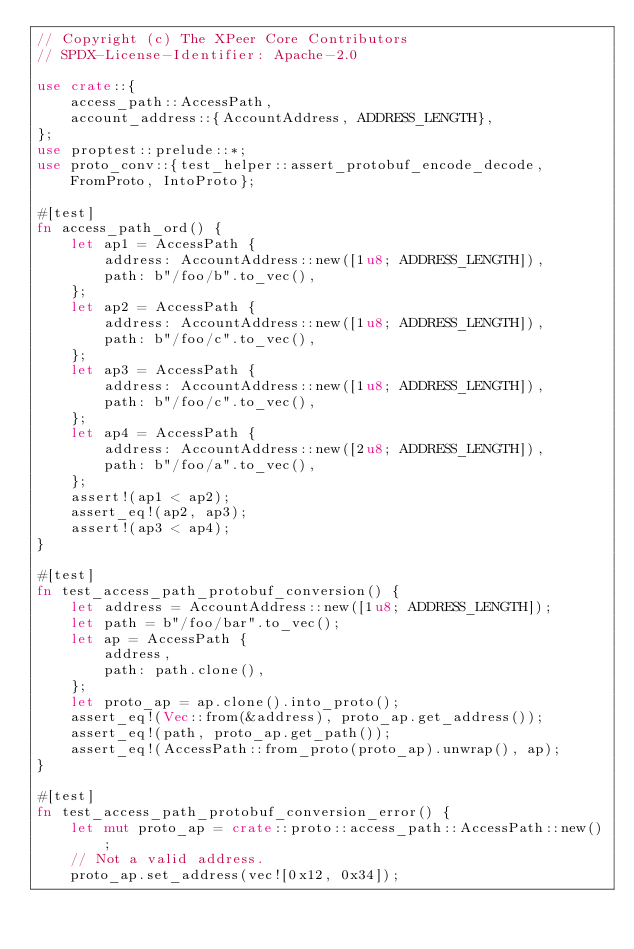Convert code to text. <code><loc_0><loc_0><loc_500><loc_500><_Rust_>// Copyright (c) The XPeer Core Contributors
// SPDX-License-Identifier: Apache-2.0

use crate::{
    access_path::AccessPath,
    account_address::{AccountAddress, ADDRESS_LENGTH},
};
use proptest::prelude::*;
use proto_conv::{test_helper::assert_protobuf_encode_decode, FromProto, IntoProto};

#[test]
fn access_path_ord() {
    let ap1 = AccessPath {
        address: AccountAddress::new([1u8; ADDRESS_LENGTH]),
        path: b"/foo/b".to_vec(),
    };
    let ap2 = AccessPath {
        address: AccountAddress::new([1u8; ADDRESS_LENGTH]),
        path: b"/foo/c".to_vec(),
    };
    let ap3 = AccessPath {
        address: AccountAddress::new([1u8; ADDRESS_LENGTH]),
        path: b"/foo/c".to_vec(),
    };
    let ap4 = AccessPath {
        address: AccountAddress::new([2u8; ADDRESS_LENGTH]),
        path: b"/foo/a".to_vec(),
    };
    assert!(ap1 < ap2);
    assert_eq!(ap2, ap3);
    assert!(ap3 < ap4);
}

#[test]
fn test_access_path_protobuf_conversion() {
    let address = AccountAddress::new([1u8; ADDRESS_LENGTH]);
    let path = b"/foo/bar".to_vec();
    let ap = AccessPath {
        address,
        path: path.clone(),
    };
    let proto_ap = ap.clone().into_proto();
    assert_eq!(Vec::from(&address), proto_ap.get_address());
    assert_eq!(path, proto_ap.get_path());
    assert_eq!(AccessPath::from_proto(proto_ap).unwrap(), ap);
}

#[test]
fn test_access_path_protobuf_conversion_error() {
    let mut proto_ap = crate::proto::access_path::AccessPath::new();
    // Not a valid address.
    proto_ap.set_address(vec![0x12, 0x34]);</code> 